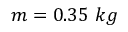Convert formula to latex. <formula><loc_0><loc_0><loc_500><loc_500>m = 0 . 3 5 \ k g</formula> 